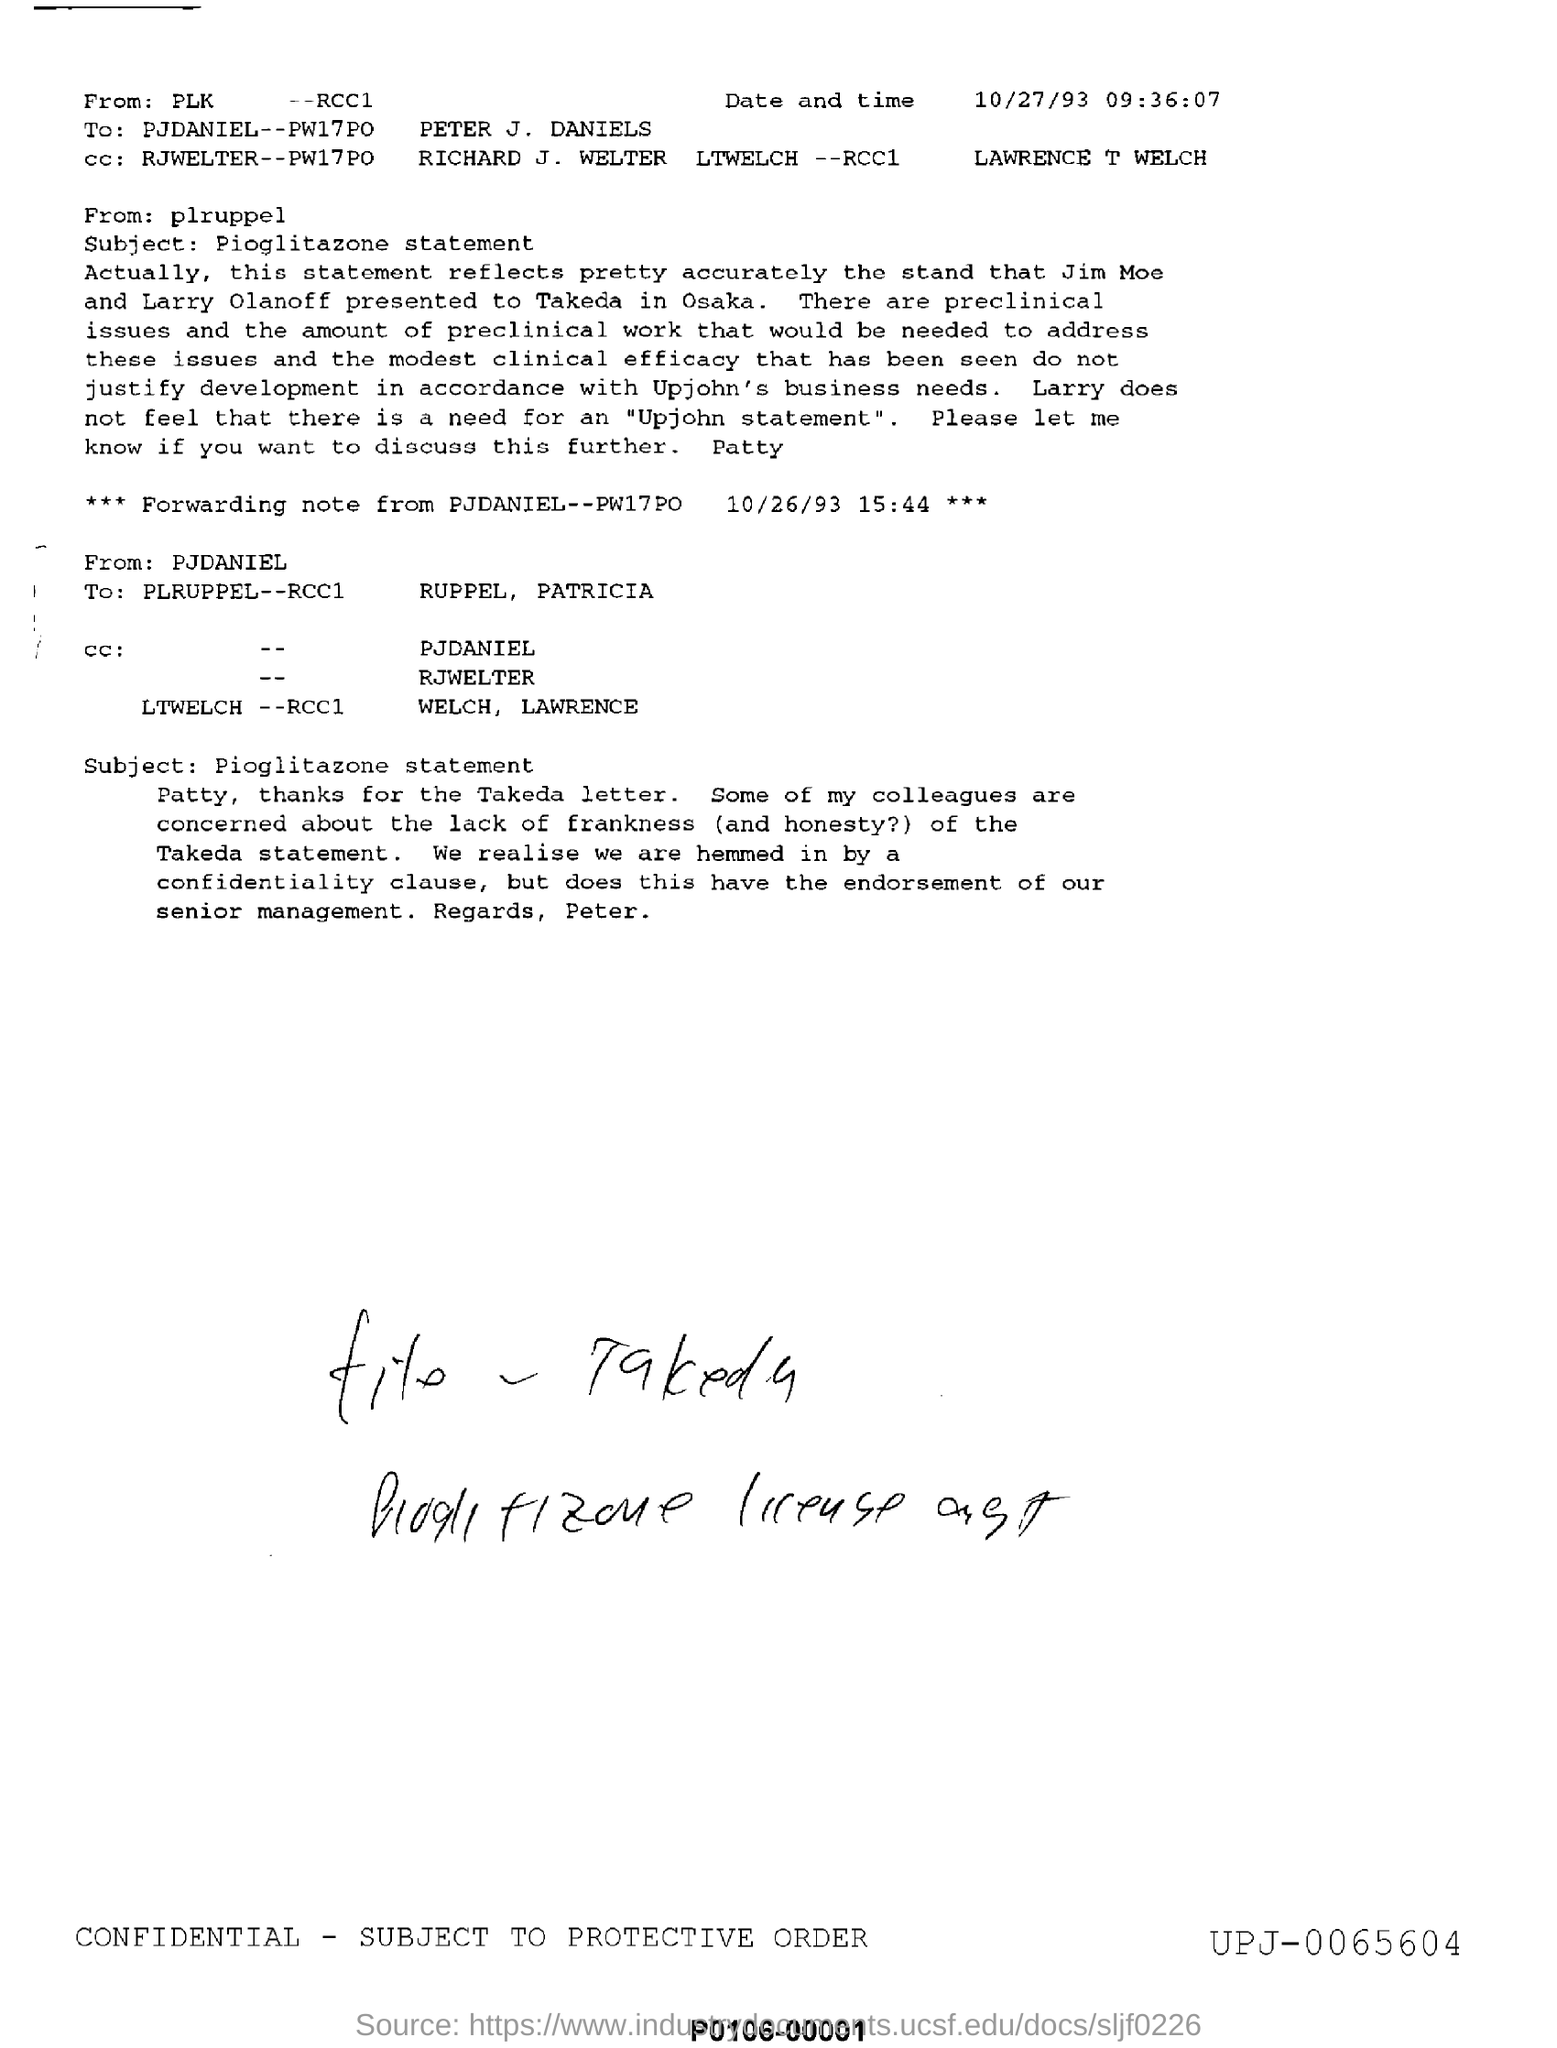Give some essential details in this illustration. The email was forwarded to "PLRUPPEL--RCC1 RUPPEL, PATRICIA.". The subject mentions pioglitazone. The subject of the email is "To whom this email was send? PETER J. DANIELS.." and it is written in the accusative case. The date mentioned in the forwarding note is 10/26/93. What is the date and time mentioned? 10/27/93 09:36:07... 